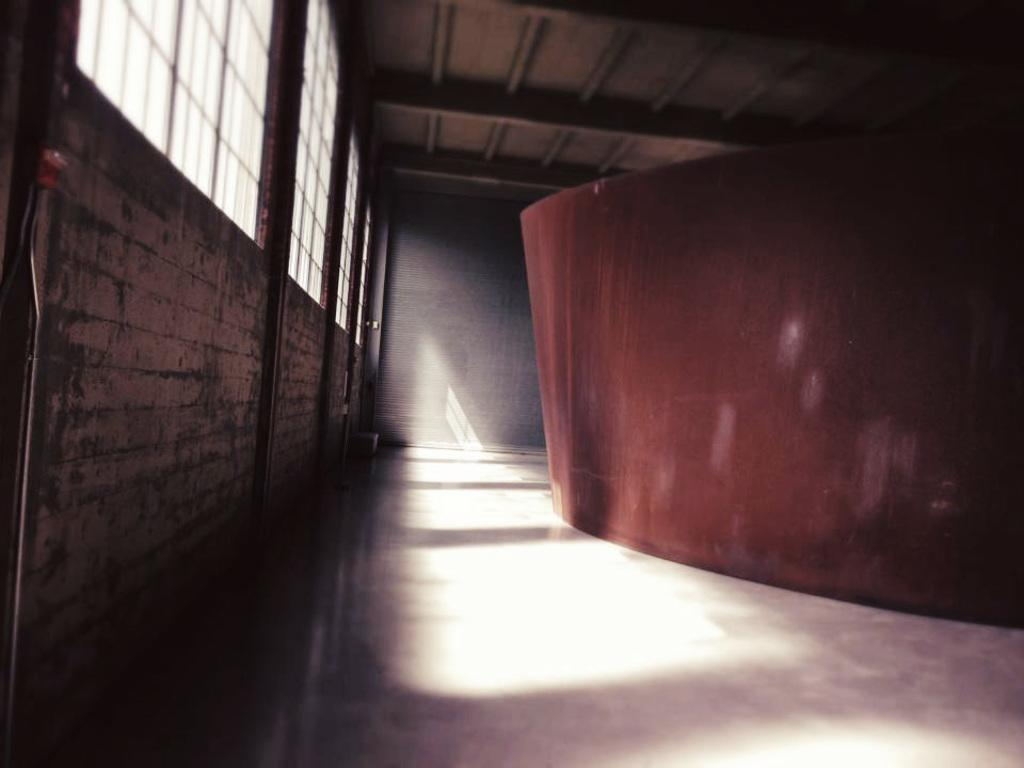What type of surface is visible at the bottom of the image? There is a floor in the image. What color is the object that stands out in the image? There is a red object in the image. What separates the interior space from the outside in the image? There is a wall in the image. What allows natural light to enter the space in the image? There are windows in the image. What is located above the space in the image? There is a ceiling in the image. Can you describe the dog sitting on the sofa in the image? There is no dog or sofa present in the image. 